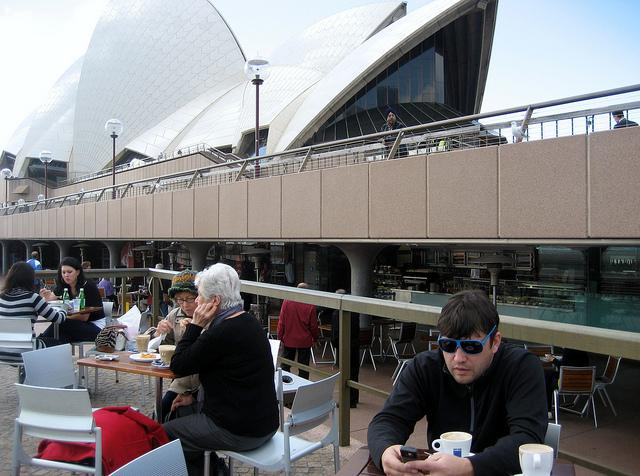What type of entertainment is commonly held in the building behind the people eating? concert 